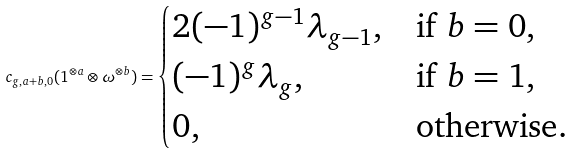<formula> <loc_0><loc_0><loc_500><loc_500>c _ { g , a + b , 0 } ( 1 ^ { \otimes a } \otimes \omega ^ { \otimes b } ) = \begin{cases} 2 ( - 1 ) ^ { g - 1 } \lambda _ { g - 1 } , & \text {if $b=0$} , \\ ( - 1 ) ^ { g } \lambda _ { g } , & \text {if $b=1$} , \\ 0 , & \text {otherwise} . \end{cases}</formula> 